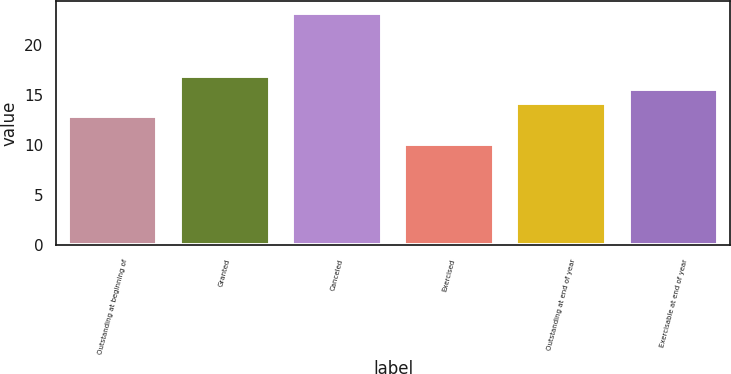<chart> <loc_0><loc_0><loc_500><loc_500><bar_chart><fcel>Outstanding at beginning of<fcel>Granted<fcel>Canceled<fcel>Exercised<fcel>Outstanding at end of year<fcel>Exercisable at end of year<nl><fcel>12.92<fcel>16.85<fcel>23.2<fcel>10.08<fcel>14.23<fcel>15.54<nl></chart> 